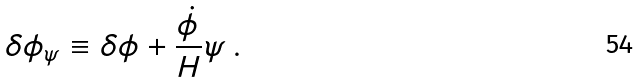<formula> <loc_0><loc_0><loc_500><loc_500>\delta \phi _ { \psi } \equiv \delta \phi + \frac { \dot { \phi } } { H } \psi \, .</formula> 